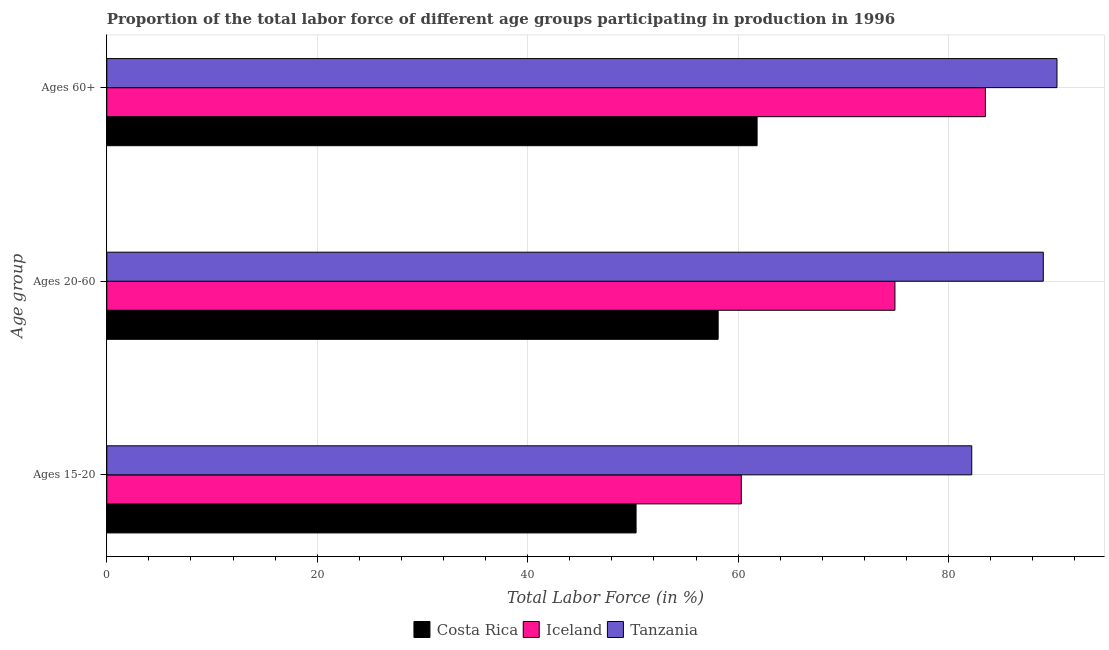How many different coloured bars are there?
Ensure brevity in your answer.  3. Are the number of bars per tick equal to the number of legend labels?
Provide a short and direct response. Yes. Are the number of bars on each tick of the Y-axis equal?
Provide a succinct answer. Yes. What is the label of the 2nd group of bars from the top?
Provide a short and direct response. Ages 20-60. What is the percentage of labor force within the age group 15-20 in Costa Rica?
Provide a succinct answer. 50.3. Across all countries, what is the maximum percentage of labor force above age 60?
Offer a terse response. 90.3. Across all countries, what is the minimum percentage of labor force within the age group 15-20?
Make the answer very short. 50.3. In which country was the percentage of labor force within the age group 15-20 maximum?
Ensure brevity in your answer.  Tanzania. What is the total percentage of labor force within the age group 20-60 in the graph?
Your answer should be compact. 222. What is the difference between the percentage of labor force within the age group 20-60 in Costa Rica and that in Tanzania?
Offer a terse response. -30.9. What is the difference between the percentage of labor force within the age group 15-20 in Iceland and the percentage of labor force above age 60 in Tanzania?
Offer a terse response. -30. What is the average percentage of labor force within the age group 20-60 per country?
Your answer should be very brief. 74. What is the difference between the percentage of labor force above age 60 and percentage of labor force within the age group 15-20 in Iceland?
Offer a very short reply. 23.2. What is the ratio of the percentage of labor force within the age group 15-20 in Iceland to that in Costa Rica?
Your answer should be very brief. 1.2. Is the difference between the percentage of labor force within the age group 20-60 in Costa Rica and Iceland greater than the difference between the percentage of labor force within the age group 15-20 in Costa Rica and Iceland?
Make the answer very short. No. What is the difference between the highest and the second highest percentage of labor force within the age group 15-20?
Give a very brief answer. 21.9. What is the difference between the highest and the lowest percentage of labor force above age 60?
Offer a terse response. 28.5. What does the 1st bar from the top in Ages 15-20 represents?
Your response must be concise. Tanzania. What does the 3rd bar from the bottom in Ages 60+ represents?
Make the answer very short. Tanzania. Is it the case that in every country, the sum of the percentage of labor force within the age group 15-20 and percentage of labor force within the age group 20-60 is greater than the percentage of labor force above age 60?
Keep it short and to the point. Yes. Are all the bars in the graph horizontal?
Provide a succinct answer. Yes. What is the difference between two consecutive major ticks on the X-axis?
Offer a very short reply. 20. Are the values on the major ticks of X-axis written in scientific E-notation?
Ensure brevity in your answer.  No. Does the graph contain grids?
Offer a very short reply. Yes. Where does the legend appear in the graph?
Your answer should be compact. Bottom center. How are the legend labels stacked?
Your answer should be very brief. Horizontal. What is the title of the graph?
Your response must be concise. Proportion of the total labor force of different age groups participating in production in 1996. What is the label or title of the Y-axis?
Your response must be concise. Age group. What is the Total Labor Force (in %) in Costa Rica in Ages 15-20?
Provide a succinct answer. 50.3. What is the Total Labor Force (in %) in Iceland in Ages 15-20?
Provide a succinct answer. 60.3. What is the Total Labor Force (in %) of Tanzania in Ages 15-20?
Give a very brief answer. 82.2. What is the Total Labor Force (in %) in Costa Rica in Ages 20-60?
Provide a short and direct response. 58.1. What is the Total Labor Force (in %) in Iceland in Ages 20-60?
Your response must be concise. 74.9. What is the Total Labor Force (in %) of Tanzania in Ages 20-60?
Ensure brevity in your answer.  89. What is the Total Labor Force (in %) in Costa Rica in Ages 60+?
Give a very brief answer. 61.8. What is the Total Labor Force (in %) in Iceland in Ages 60+?
Your answer should be very brief. 83.5. What is the Total Labor Force (in %) of Tanzania in Ages 60+?
Your answer should be compact. 90.3. Across all Age group, what is the maximum Total Labor Force (in %) in Costa Rica?
Keep it short and to the point. 61.8. Across all Age group, what is the maximum Total Labor Force (in %) of Iceland?
Your answer should be very brief. 83.5. Across all Age group, what is the maximum Total Labor Force (in %) of Tanzania?
Ensure brevity in your answer.  90.3. Across all Age group, what is the minimum Total Labor Force (in %) in Costa Rica?
Keep it short and to the point. 50.3. Across all Age group, what is the minimum Total Labor Force (in %) of Iceland?
Provide a succinct answer. 60.3. Across all Age group, what is the minimum Total Labor Force (in %) of Tanzania?
Ensure brevity in your answer.  82.2. What is the total Total Labor Force (in %) of Costa Rica in the graph?
Ensure brevity in your answer.  170.2. What is the total Total Labor Force (in %) of Iceland in the graph?
Ensure brevity in your answer.  218.7. What is the total Total Labor Force (in %) of Tanzania in the graph?
Your answer should be very brief. 261.5. What is the difference between the Total Labor Force (in %) in Iceland in Ages 15-20 and that in Ages 20-60?
Give a very brief answer. -14.6. What is the difference between the Total Labor Force (in %) in Iceland in Ages 15-20 and that in Ages 60+?
Keep it short and to the point. -23.2. What is the difference between the Total Labor Force (in %) of Iceland in Ages 20-60 and that in Ages 60+?
Your answer should be very brief. -8.6. What is the difference between the Total Labor Force (in %) in Costa Rica in Ages 15-20 and the Total Labor Force (in %) in Iceland in Ages 20-60?
Ensure brevity in your answer.  -24.6. What is the difference between the Total Labor Force (in %) in Costa Rica in Ages 15-20 and the Total Labor Force (in %) in Tanzania in Ages 20-60?
Provide a short and direct response. -38.7. What is the difference between the Total Labor Force (in %) of Iceland in Ages 15-20 and the Total Labor Force (in %) of Tanzania in Ages 20-60?
Ensure brevity in your answer.  -28.7. What is the difference between the Total Labor Force (in %) in Costa Rica in Ages 15-20 and the Total Labor Force (in %) in Iceland in Ages 60+?
Ensure brevity in your answer.  -33.2. What is the difference between the Total Labor Force (in %) in Costa Rica in Ages 15-20 and the Total Labor Force (in %) in Tanzania in Ages 60+?
Your response must be concise. -40. What is the difference between the Total Labor Force (in %) of Costa Rica in Ages 20-60 and the Total Labor Force (in %) of Iceland in Ages 60+?
Your answer should be compact. -25.4. What is the difference between the Total Labor Force (in %) in Costa Rica in Ages 20-60 and the Total Labor Force (in %) in Tanzania in Ages 60+?
Offer a terse response. -32.2. What is the difference between the Total Labor Force (in %) in Iceland in Ages 20-60 and the Total Labor Force (in %) in Tanzania in Ages 60+?
Provide a succinct answer. -15.4. What is the average Total Labor Force (in %) in Costa Rica per Age group?
Ensure brevity in your answer.  56.73. What is the average Total Labor Force (in %) in Iceland per Age group?
Provide a short and direct response. 72.9. What is the average Total Labor Force (in %) in Tanzania per Age group?
Offer a terse response. 87.17. What is the difference between the Total Labor Force (in %) in Costa Rica and Total Labor Force (in %) in Iceland in Ages 15-20?
Give a very brief answer. -10. What is the difference between the Total Labor Force (in %) of Costa Rica and Total Labor Force (in %) of Tanzania in Ages 15-20?
Offer a very short reply. -31.9. What is the difference between the Total Labor Force (in %) in Iceland and Total Labor Force (in %) in Tanzania in Ages 15-20?
Give a very brief answer. -21.9. What is the difference between the Total Labor Force (in %) in Costa Rica and Total Labor Force (in %) in Iceland in Ages 20-60?
Give a very brief answer. -16.8. What is the difference between the Total Labor Force (in %) in Costa Rica and Total Labor Force (in %) in Tanzania in Ages 20-60?
Your response must be concise. -30.9. What is the difference between the Total Labor Force (in %) in Iceland and Total Labor Force (in %) in Tanzania in Ages 20-60?
Offer a terse response. -14.1. What is the difference between the Total Labor Force (in %) of Costa Rica and Total Labor Force (in %) of Iceland in Ages 60+?
Provide a short and direct response. -21.7. What is the difference between the Total Labor Force (in %) in Costa Rica and Total Labor Force (in %) in Tanzania in Ages 60+?
Offer a terse response. -28.5. What is the ratio of the Total Labor Force (in %) of Costa Rica in Ages 15-20 to that in Ages 20-60?
Your answer should be compact. 0.87. What is the ratio of the Total Labor Force (in %) in Iceland in Ages 15-20 to that in Ages 20-60?
Offer a very short reply. 0.81. What is the ratio of the Total Labor Force (in %) of Tanzania in Ages 15-20 to that in Ages 20-60?
Your answer should be very brief. 0.92. What is the ratio of the Total Labor Force (in %) of Costa Rica in Ages 15-20 to that in Ages 60+?
Make the answer very short. 0.81. What is the ratio of the Total Labor Force (in %) of Iceland in Ages 15-20 to that in Ages 60+?
Offer a terse response. 0.72. What is the ratio of the Total Labor Force (in %) of Tanzania in Ages 15-20 to that in Ages 60+?
Your response must be concise. 0.91. What is the ratio of the Total Labor Force (in %) of Costa Rica in Ages 20-60 to that in Ages 60+?
Offer a terse response. 0.94. What is the ratio of the Total Labor Force (in %) in Iceland in Ages 20-60 to that in Ages 60+?
Your answer should be very brief. 0.9. What is the ratio of the Total Labor Force (in %) in Tanzania in Ages 20-60 to that in Ages 60+?
Give a very brief answer. 0.99. What is the difference between the highest and the second highest Total Labor Force (in %) in Costa Rica?
Make the answer very short. 3.7. What is the difference between the highest and the second highest Total Labor Force (in %) of Tanzania?
Your response must be concise. 1.3. What is the difference between the highest and the lowest Total Labor Force (in %) of Costa Rica?
Your answer should be very brief. 11.5. What is the difference between the highest and the lowest Total Labor Force (in %) in Iceland?
Offer a terse response. 23.2. What is the difference between the highest and the lowest Total Labor Force (in %) of Tanzania?
Provide a succinct answer. 8.1. 